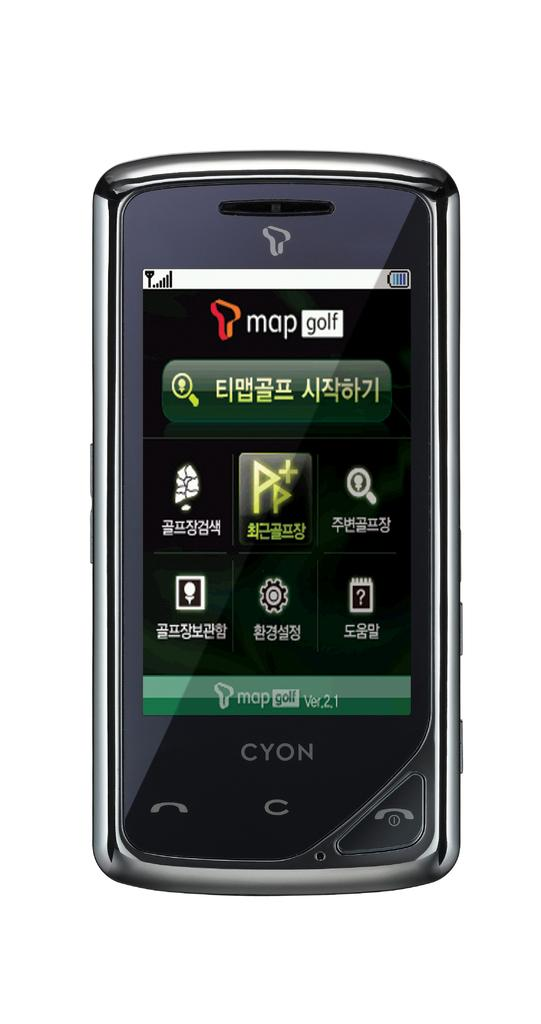<image>
Summarize the visual content of the image. A cell phone with "mop golf" and asian text on it. 